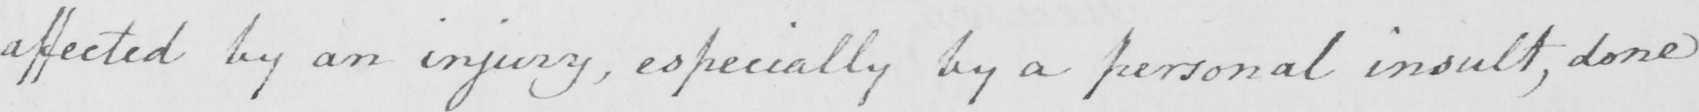Can you read and transcribe this handwriting? affected by an injury , especially by a personal insult , done 